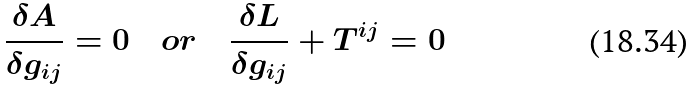<formula> <loc_0><loc_0><loc_500><loc_500>\frac { { \delta } A } { { \delta } g _ { i j } } = 0 { \quad } o r \quad \frac { { \delta } L } { { \delta } g _ { i j } } + T ^ { i j } = 0</formula> 